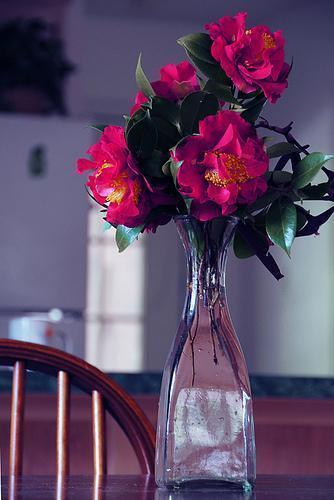How many vases are in the picture?
Give a very brief answer. 1. 